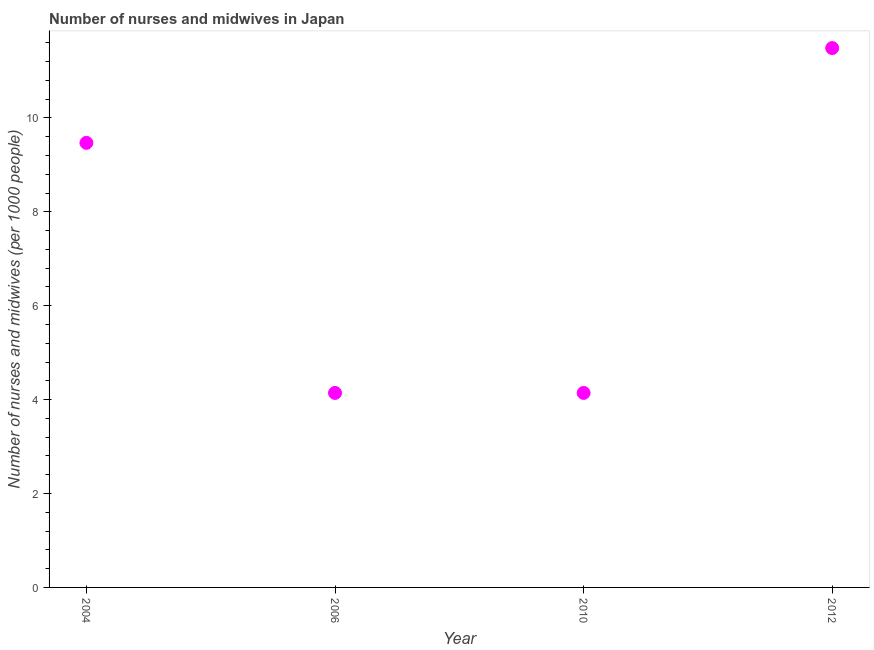What is the number of nurses and midwives in 2010?
Give a very brief answer. 4.14. Across all years, what is the maximum number of nurses and midwives?
Offer a very short reply. 11.49. Across all years, what is the minimum number of nurses and midwives?
Make the answer very short. 4.14. In which year was the number of nurses and midwives minimum?
Your answer should be compact. 2006. What is the sum of the number of nurses and midwives?
Your answer should be very brief. 29.25. What is the difference between the number of nurses and midwives in 2004 and 2012?
Keep it short and to the point. -2.02. What is the average number of nurses and midwives per year?
Keep it short and to the point. 7.31. What is the median number of nurses and midwives?
Keep it short and to the point. 6.81. Do a majority of the years between 2012 and 2010 (inclusive) have number of nurses and midwives greater than 7.2 ?
Your response must be concise. No. What is the ratio of the number of nurses and midwives in 2004 to that in 2010?
Keep it short and to the point. 2.29. Is the number of nurses and midwives in 2010 less than that in 2012?
Your response must be concise. Yes. What is the difference between the highest and the second highest number of nurses and midwives?
Your response must be concise. 2.02. What is the difference between the highest and the lowest number of nurses and midwives?
Keep it short and to the point. 7.35. In how many years, is the number of nurses and midwives greater than the average number of nurses and midwives taken over all years?
Ensure brevity in your answer.  2. How many years are there in the graph?
Ensure brevity in your answer.  4. What is the difference between two consecutive major ticks on the Y-axis?
Give a very brief answer. 2. Does the graph contain any zero values?
Give a very brief answer. No. Does the graph contain grids?
Offer a very short reply. No. What is the title of the graph?
Ensure brevity in your answer.  Number of nurses and midwives in Japan. What is the label or title of the X-axis?
Provide a short and direct response. Year. What is the label or title of the Y-axis?
Give a very brief answer. Number of nurses and midwives (per 1000 people). What is the Number of nurses and midwives (per 1000 people) in 2004?
Ensure brevity in your answer.  9.47. What is the Number of nurses and midwives (per 1000 people) in 2006?
Offer a very short reply. 4.14. What is the Number of nurses and midwives (per 1000 people) in 2010?
Offer a very short reply. 4.14. What is the Number of nurses and midwives (per 1000 people) in 2012?
Your answer should be compact. 11.49. What is the difference between the Number of nurses and midwives (per 1000 people) in 2004 and 2006?
Provide a succinct answer. 5.33. What is the difference between the Number of nurses and midwives (per 1000 people) in 2004 and 2010?
Give a very brief answer. 5.33. What is the difference between the Number of nurses and midwives (per 1000 people) in 2004 and 2012?
Your response must be concise. -2.02. What is the difference between the Number of nurses and midwives (per 1000 people) in 2006 and 2010?
Your answer should be very brief. 0. What is the difference between the Number of nurses and midwives (per 1000 people) in 2006 and 2012?
Offer a very short reply. -7.35. What is the difference between the Number of nurses and midwives (per 1000 people) in 2010 and 2012?
Provide a short and direct response. -7.35. What is the ratio of the Number of nurses and midwives (per 1000 people) in 2004 to that in 2006?
Give a very brief answer. 2.29. What is the ratio of the Number of nurses and midwives (per 1000 people) in 2004 to that in 2010?
Give a very brief answer. 2.29. What is the ratio of the Number of nurses and midwives (per 1000 people) in 2004 to that in 2012?
Give a very brief answer. 0.82. What is the ratio of the Number of nurses and midwives (per 1000 people) in 2006 to that in 2010?
Ensure brevity in your answer.  1. What is the ratio of the Number of nurses and midwives (per 1000 people) in 2006 to that in 2012?
Keep it short and to the point. 0.36. What is the ratio of the Number of nurses and midwives (per 1000 people) in 2010 to that in 2012?
Provide a short and direct response. 0.36. 